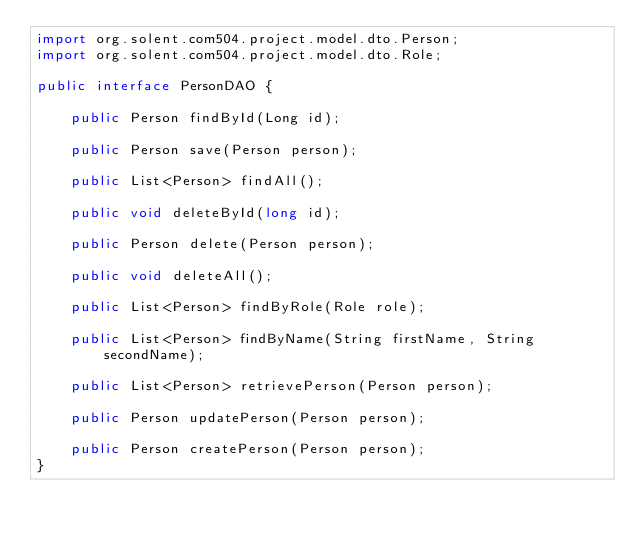<code> <loc_0><loc_0><loc_500><loc_500><_Java_>import org.solent.com504.project.model.dto.Person;
import org.solent.com504.project.model.dto.Role;

public interface PersonDAO {

    public Person findById(Long id);

    public Person save(Person person);

    public List<Person> findAll();

    public void deleteById(long id);

    public Person delete(Person person);

    public void deleteAll();

    public List<Person> findByRole(Role role);

    public List<Person> findByName(String firstName, String secondName);
    
    public List<Person> retrievePerson(Person person);

    public Person updatePerson(Person person);
    
    public Person createPerson(Person person);
}
</code> 